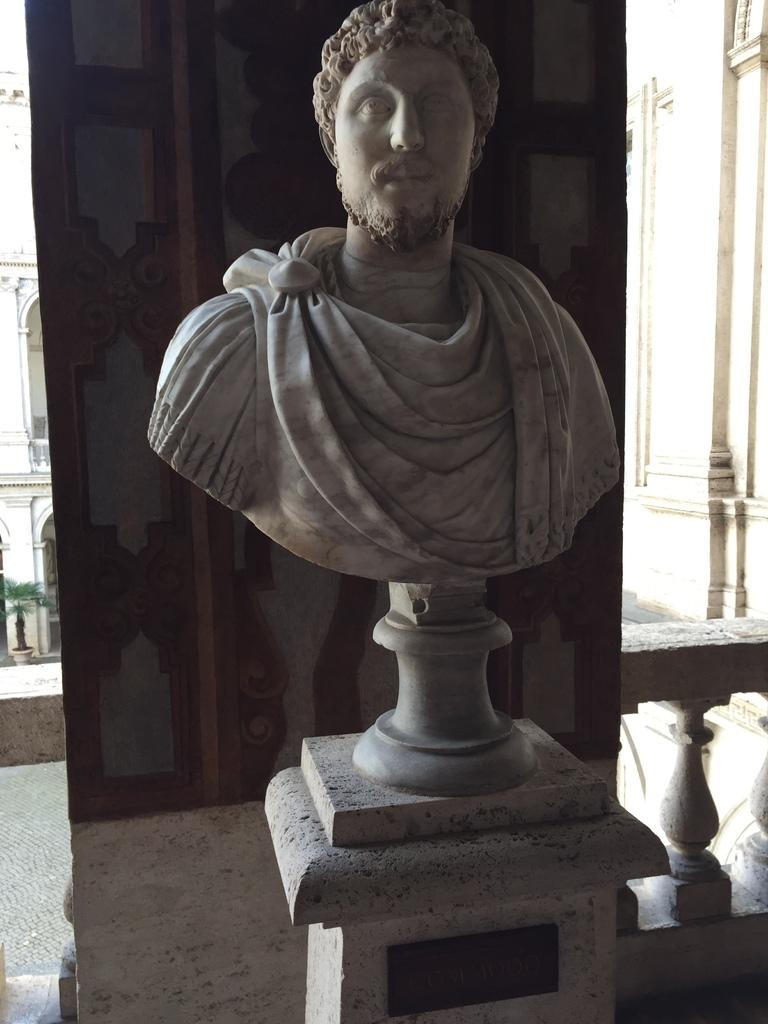What is the main subject of the image? There is a sculpture in the image. What is behind the sculpture? There is a wall behind the sculpture. What can be seen in the background of the image? There is a potted plant and a building in the background of the image. How much debt does the manager of the building in the background owe? There is no information about the building's manager or any debt in the image. 